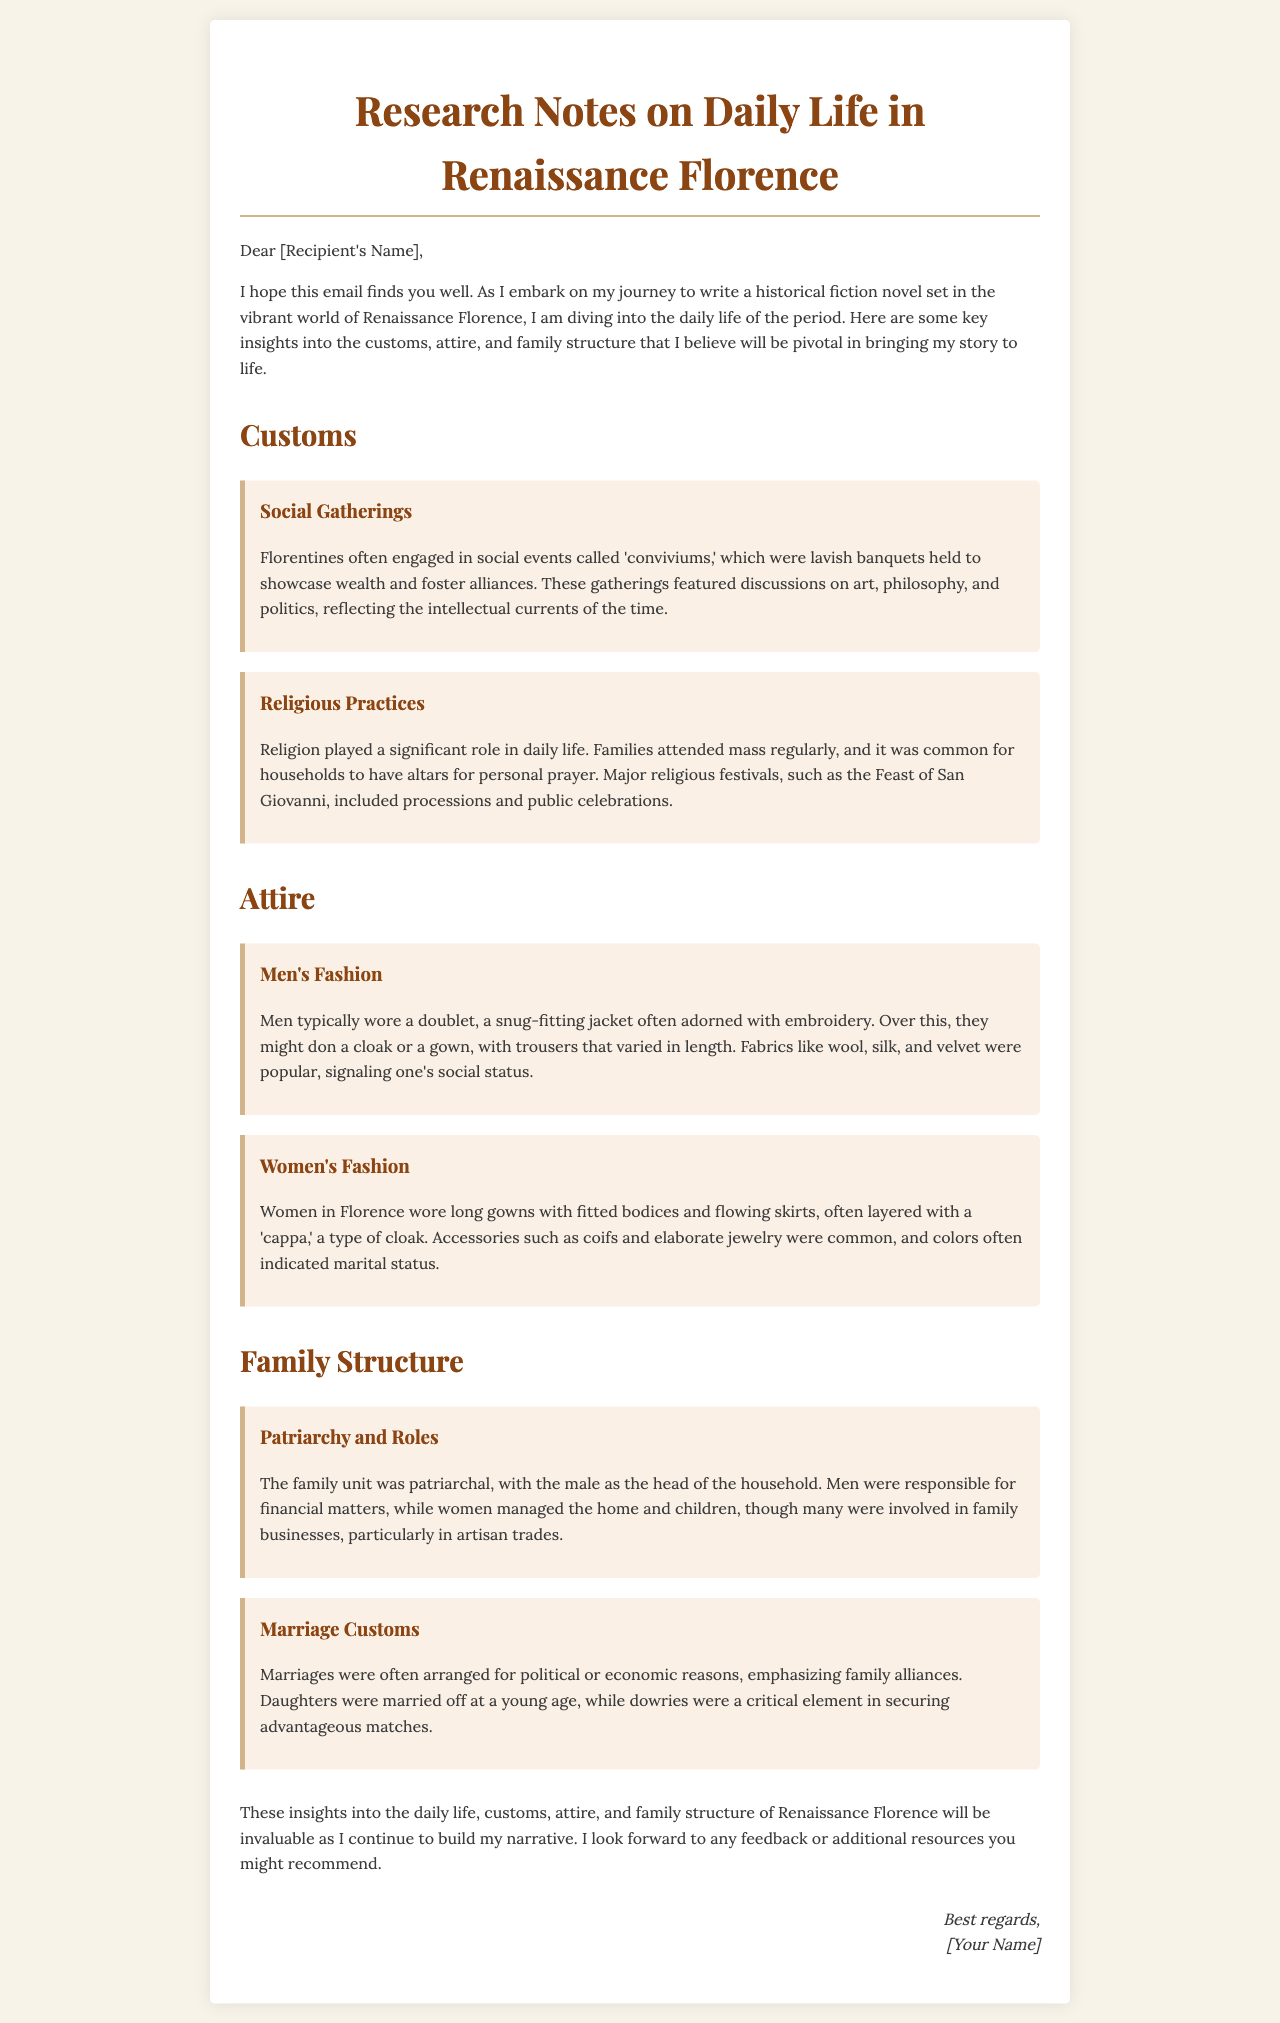What is the main topic of the document? The document provides insights into daily life in Renaissance Florence, focusing on customs, attire, and family structure.
Answer: Daily life in Renaissance Florence How are social gatherings referred to? The document mentions social events called 'conviviums'.
Answer: conviviums What type of clothing did men typically wear? The document states that men typically wore a doublet, often adorned with embroidery.
Answer: doublet What role did men play in the family structure? The document states that the male was the head of the household and responsible for financial matters.
Answer: head of the household What was the purpose of marriages in Renaissance Florence? Marriages were often arranged for political or economic reasons to emphasize family alliances.
Answer: political or economic reasons What is a common accessory for women in Florence? The document mentions that accessories such as coifs were common for women.
Answer: coifs What is a significant religious festival mentioned? The document lists the Feast of San Giovanni as a major religious festival in Florence.
Answer: Feast of San Giovanni What type of fabric was popular for men's fashion? The document states that fabrics like wool, silk, and velvet were popular among men.
Answer: wool, silk, and velvet How does the document end? The document concludes with a request for feedback or additional resources related to the research.
Answer: feedback or additional resources 